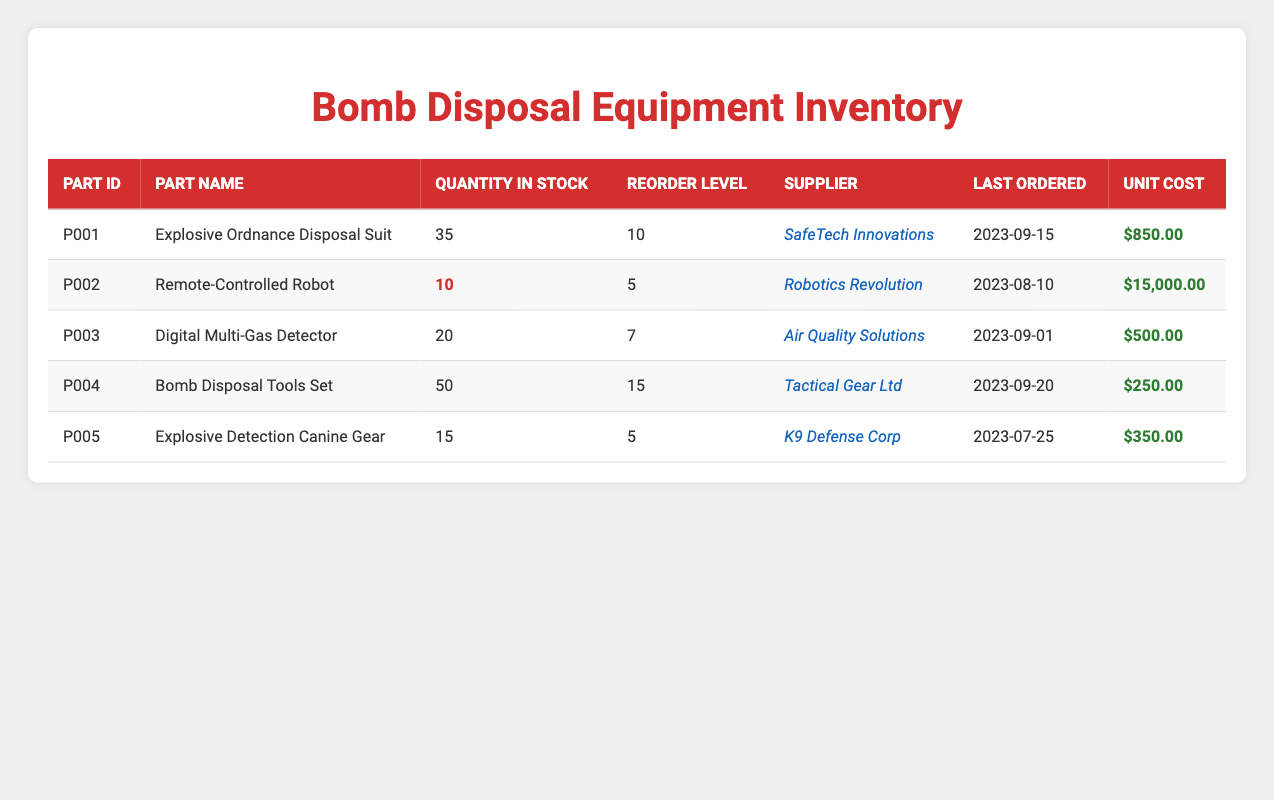What part has the highest quantity in stock? The part with the highest quantity in stock can be found by comparing the stock levels of all parts. The Bomb Disposal Tools Set has 50 units, which is more than any other part listed in the inventory.
Answer: Bomb Disposal Tools Set How much does the Remote-Controlled Robot cost? To answer this, we look for the row that lists the Remote-Controlled Robot in the table. The unit cost listed for this part is $15,000.00.
Answer: $15,000.00 Is the quantity in stock for the Explosive Ordnance Disposal Suit below its reorder level? The quantity in stock for the Explosive Ordnance Disposal Suit is 35, and its reorder level is 10. Since 35 is greater than 10, the statement is false.
Answer: No What is the total quantity of stock available for parts that have a reorder level greater than 10? First, I will identify parts with a reorder level greater than 10, which are the Bomb Disposal Tools Set (50) and Explosive Ordnance Disposal Suit (35). Adding these quantities gives: 50 + 35 = 85.
Answer: 85 Which part is supplied by K9 Defense Corp? By checking the supplier column, the part listed under K9 Defense Corp is the Explosive Detection Canine Gear.
Answer: Explosive Detection Canine Gear How many parts are currently below their reorder levels? Evaluating the stock levels against their reorder levels: The Remote-Controlled Robot (10 below 5), and Explosive Detection Canine Gear (15 below 5). This means there are 2 parts below their reorder levels.
Answer: 2 What is the average unit cost of all parts in the inventory? To find the average, first sum all unit costs: $850 + $15,000 + $500 + $250 + $350 = $16,950. Next, divide the total by the number of parts (5): $16,950 / 5 = $3,390.
Answer: $3,390 Was the last order date for the Digital Multi-Gas Detector before September 1, 2023? The last ordered date for the Digital Multi-Gas Detector is September 1, 2023. Thus, it was not before this date, making the statement false.
Answer: No 